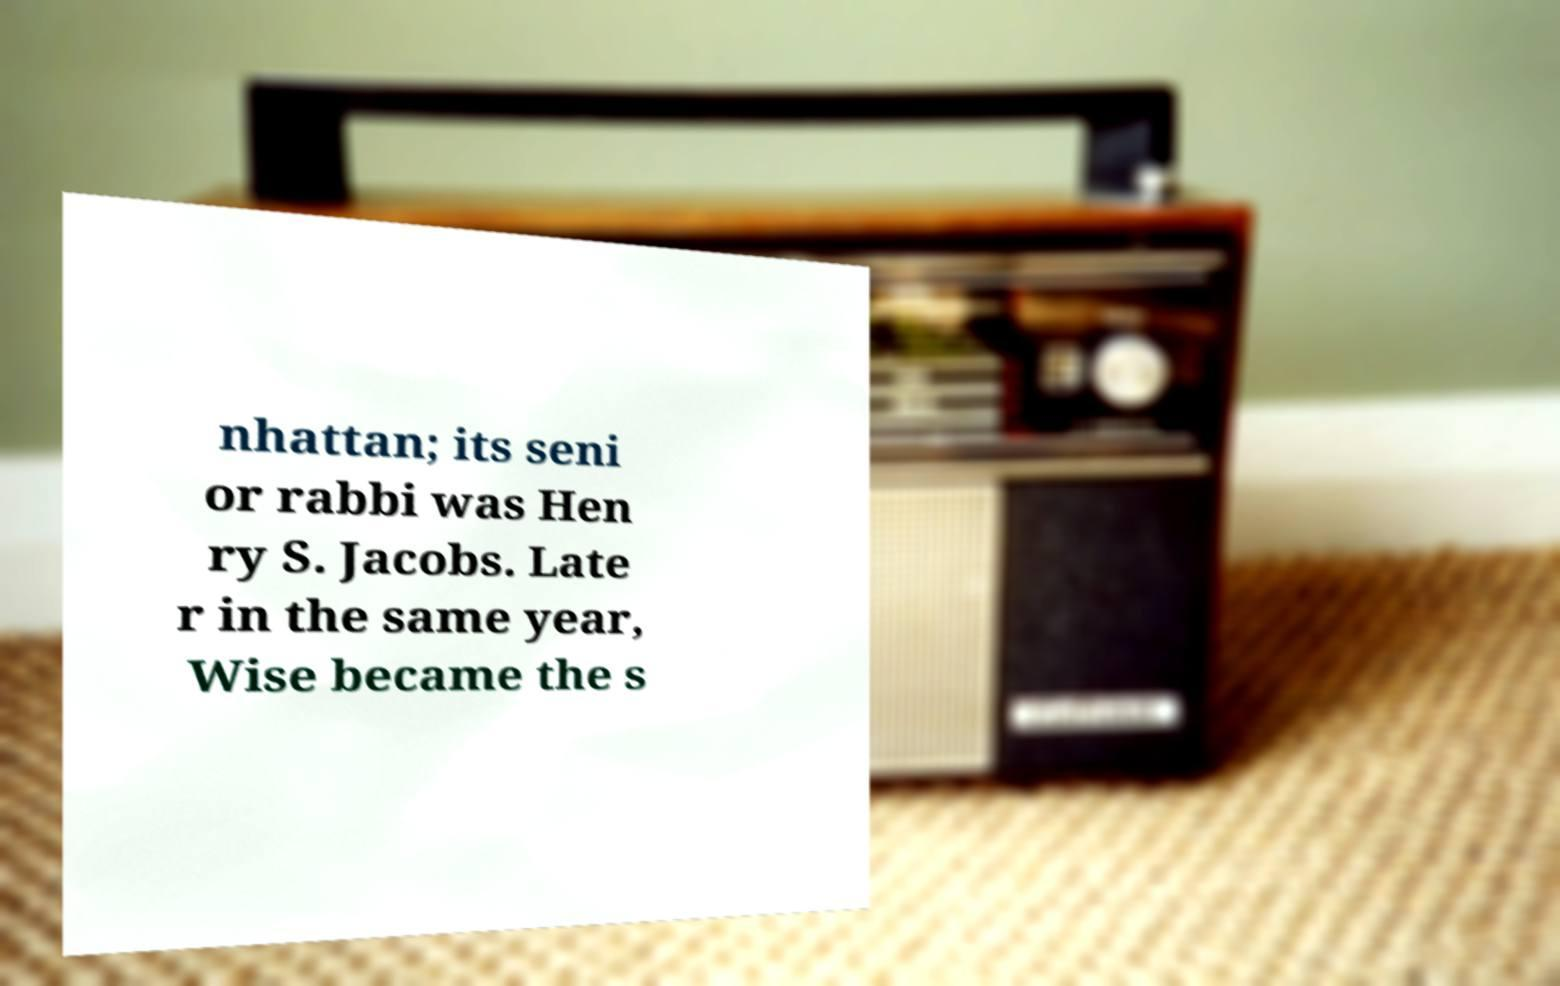Please identify and transcribe the text found in this image. nhattan; its seni or rabbi was Hen ry S. Jacobs. Late r in the same year, Wise became the s 